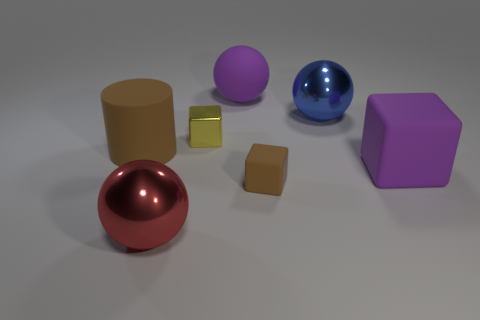Subtract all matte balls. How many balls are left? 2 Add 3 large cylinders. How many objects exist? 10 Subtract 3 cubes. How many cubes are left? 0 Subtract all red balls. How many balls are left? 2 Subtract all cubes. How many objects are left? 4 Subtract 0 green blocks. How many objects are left? 7 Subtract all blue cylinders. Subtract all red cubes. How many cylinders are left? 1 Subtract all matte things. Subtract all large blue things. How many objects are left? 2 Add 7 tiny brown blocks. How many tiny brown blocks are left? 8 Add 4 spheres. How many spheres exist? 7 